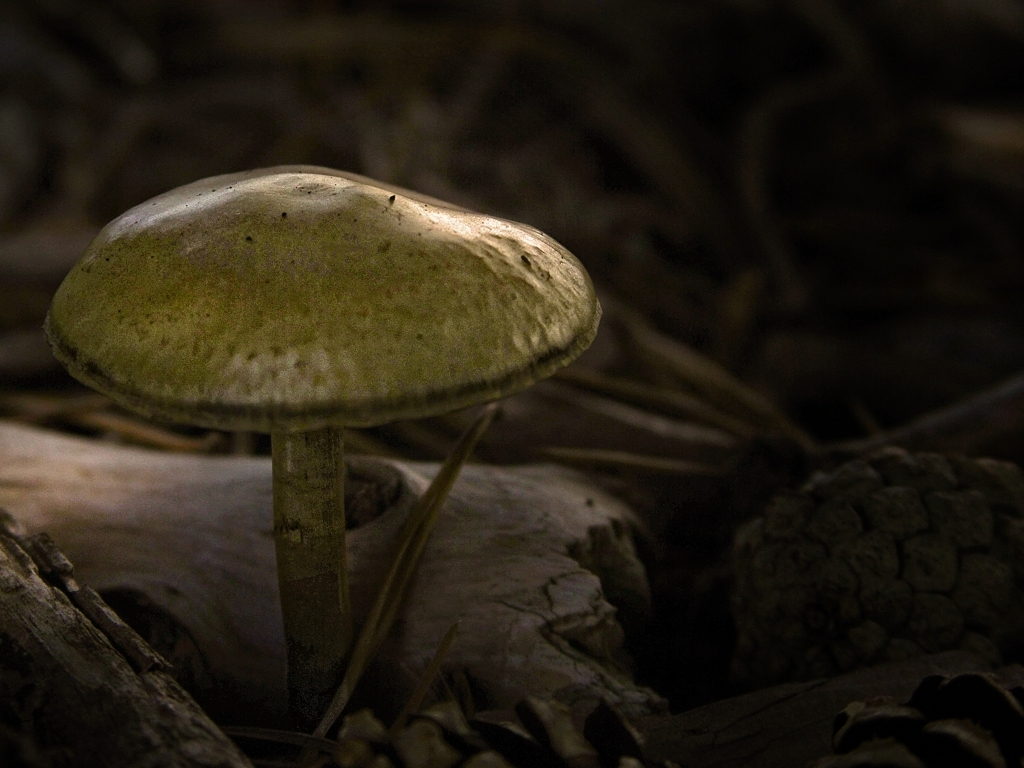What kind of environment is this mushroom growing in? This mushroom is growing in a forested area with plenty of organic matter, such as fallen leaves and pine cones, which provide a rich substrate for it to thrive in. 